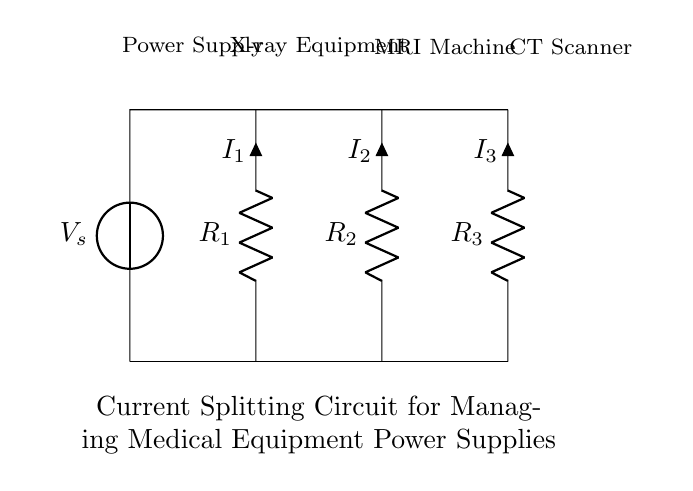What is the total current entering the circuit? The total current entering the circuit is represented by the source voltage divided by the total resistance of the circuit. However, since the circuit diagram does not provide specific values for voltages or resistances, this question cannot be answered with a numerical value without that information. The answer depends on those values.
Answer: Undefined What are the resistances in the circuit? The resistances present in the circuit are identified as R1, R2, and R3, which are explicitly labeled on the diagram.
Answer: R1, R2, R3 What is the direction of current flow? The current flows from the voltage source downwards through the resistors to the ground. This can be inferred from the diagram's layout where the components connect vertically.
Answer: Downwards How many branches are in the current divider? The current divider has three branches connected in parallel, as shown by the three resistors R1, R2, and R3 receiving the same voltage from the power supply.
Answer: Three What type of components are used in this circuit? The components used are resistors and a voltage source, which are common in electrical circuits for controlling current and voltage.
Answer: Resistors, Voltage Source Which resistor has the highest current passing through it? The current passing through each resistor depends on their resistance values. If the value of a resistor decreases, more current will pass through it according to Ohm's Law. Since the values are not provided, we cannot identify which resistor has the highest current.
Answer: Undefined What is the purpose of a current divider in this circuit? The purpose of a current divider is to split the total current into smaller currents that flow through each parallel branch. This ensures that multiple medical devices can be powered simultaneously with the proper share of the current.
Answer: To split current 